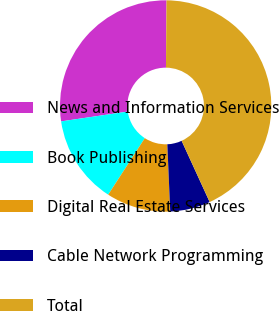<chart> <loc_0><loc_0><loc_500><loc_500><pie_chart><fcel>News and Information Services<fcel>Book Publishing<fcel>Digital Real Estate Services<fcel>Cable Network Programming<fcel>Total<nl><fcel>27.46%<fcel>13.52%<fcel>9.84%<fcel>6.15%<fcel>43.03%<nl></chart> 